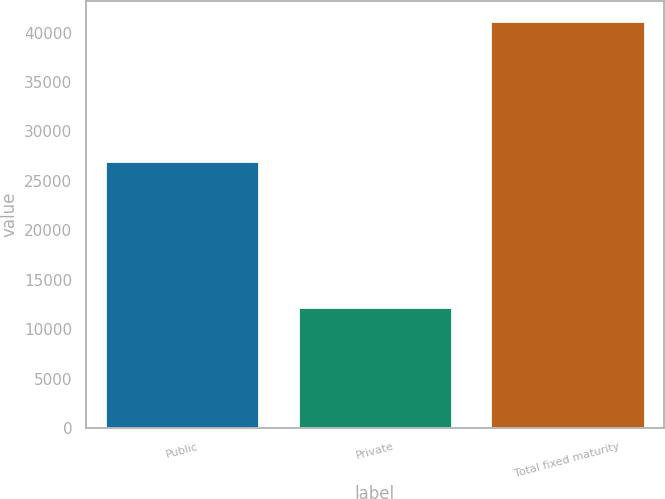<chart> <loc_0><loc_0><loc_500><loc_500><bar_chart><fcel>Public<fcel>Private<fcel>Total fixed maturity<nl><fcel>26995.7<fcel>12292.4<fcel>41188.7<nl></chart> 